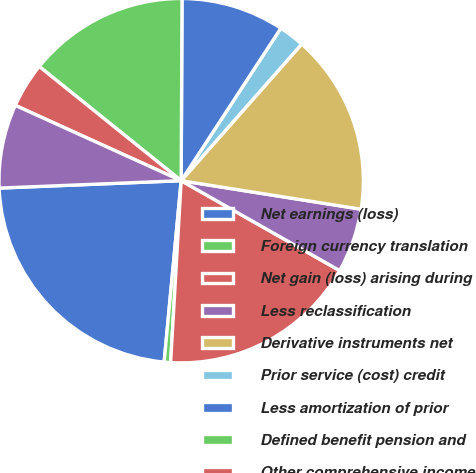Convert chart. <chart><loc_0><loc_0><loc_500><loc_500><pie_chart><fcel>Net earnings (loss)<fcel>Foreign currency translation<fcel>Net gain (loss) arising during<fcel>Less reclassification<fcel>Derivative instruments net<fcel>Prior service (cost) credit<fcel>Less amortization of prior<fcel>Defined benefit pension and<fcel>Other comprehensive income<fcel>Income tax benefit (expense)<nl><fcel>22.86%<fcel>0.57%<fcel>17.71%<fcel>5.71%<fcel>16.0%<fcel>2.29%<fcel>9.14%<fcel>14.29%<fcel>4.0%<fcel>7.43%<nl></chart> 